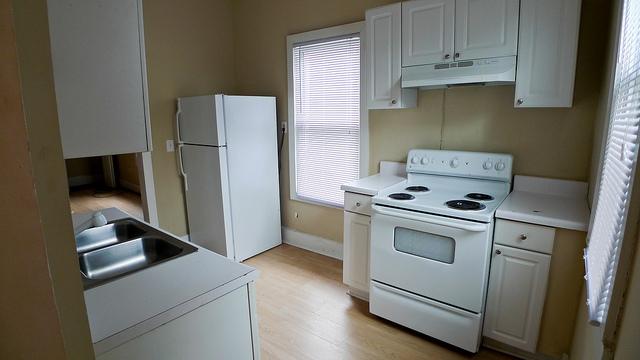What color paint is on the walls?
Short answer required. Tan. Is this an electric oven?
Short answer required. Yes. Is this a modern oven?
Be succinct. Yes. Is this kitchen big?
Short answer required. No. 